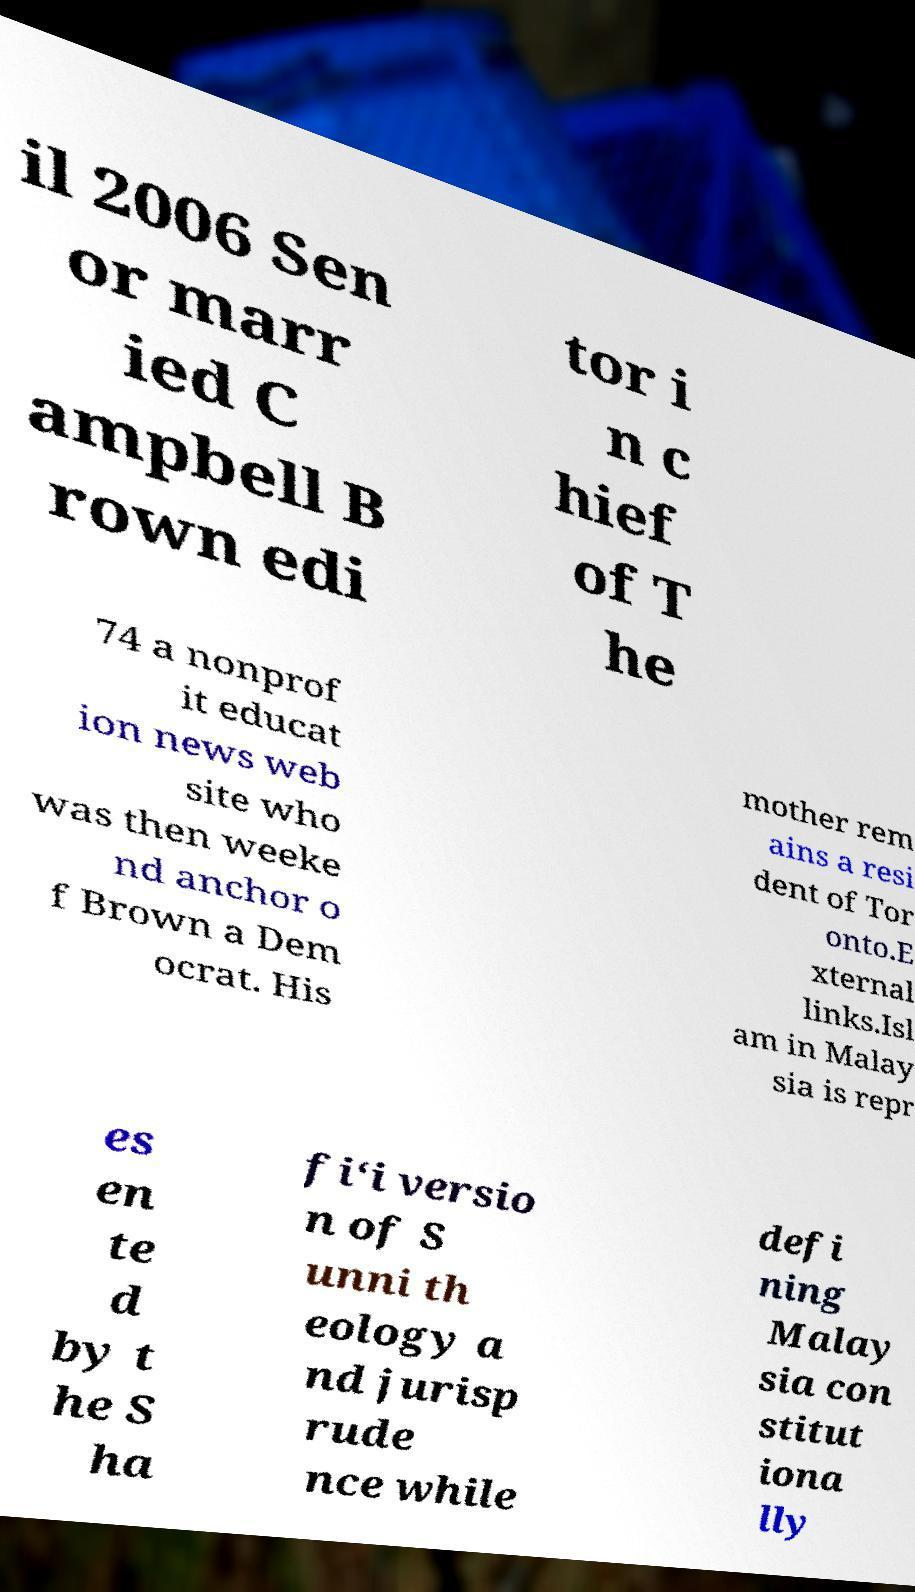Can you accurately transcribe the text from the provided image for me? il 2006 Sen or marr ied C ampbell B rown edi tor i n c hief of T he 74 a nonprof it educat ion news web site who was then weeke nd anchor o f Brown a Dem ocrat. His mother rem ains a resi dent of Tor onto.E xternal links.Isl am in Malay sia is repr es en te d by t he S ha fi‘i versio n of S unni th eology a nd jurisp rude nce while defi ning Malay sia con stitut iona lly 